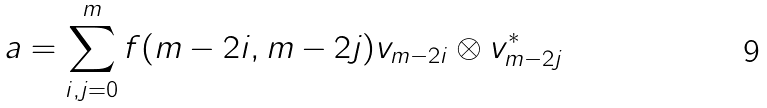<formula> <loc_0><loc_0><loc_500><loc_500>a = \sum _ { i , j = 0 } ^ { m } f ( m - 2 i , m - 2 j ) v _ { m - 2 i } \otimes v _ { m - 2 j } ^ { * }</formula> 